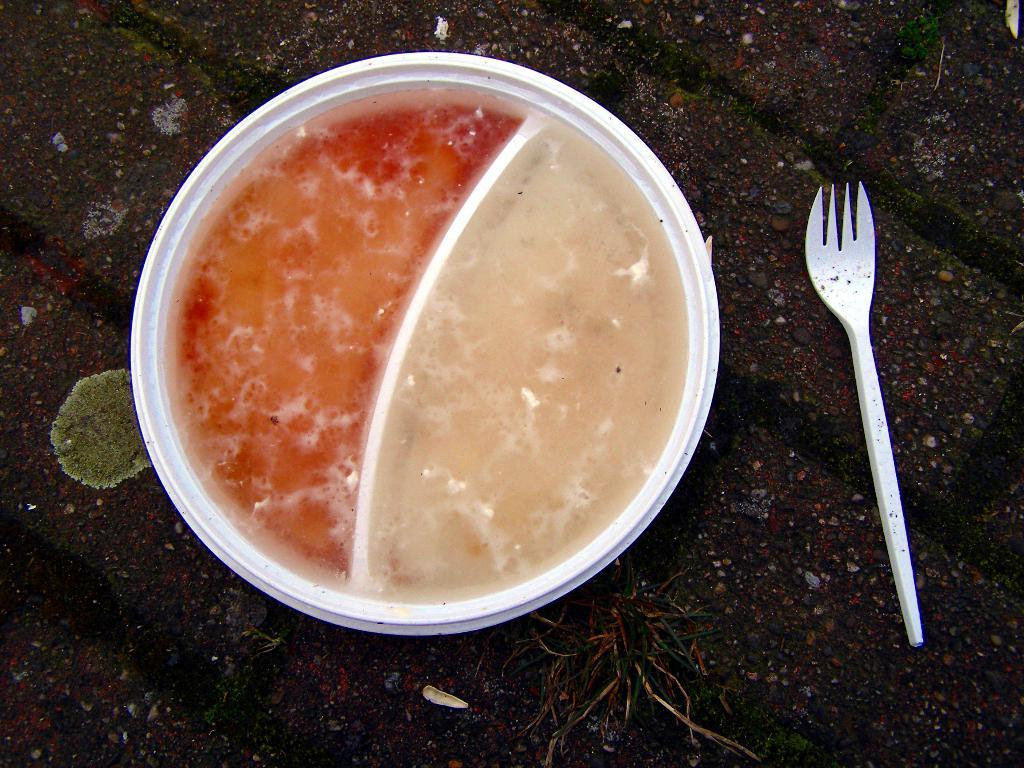What type of bowl is in the image? There is a white colored partitioned bowl in the image. What color is some of the food in the bowl? Some of the food in the bowl is red in color. What utensil is visible in the image? There is a fork visible in the image. Where is the oven located in the image? There is no oven present in the image. Can you tell me how many people are in the group eating the food in the image? There is no group of people present in the image; it only shows a bowl of food and a fork. 